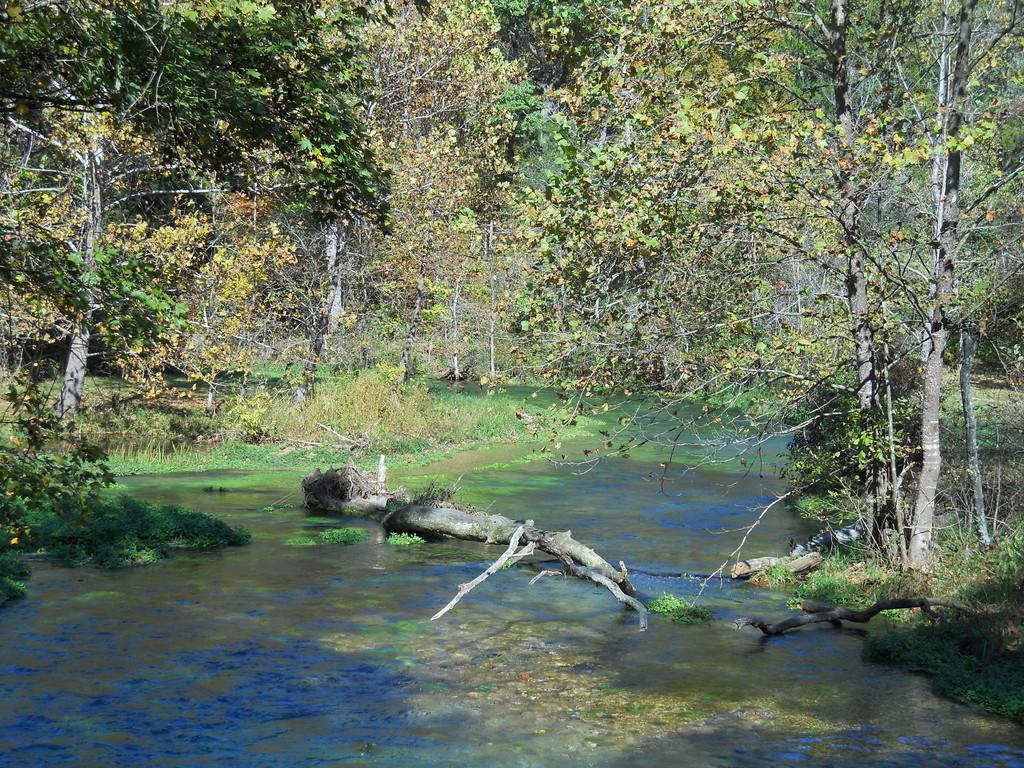In one or two sentences, can you explain what this image depicts? In this image, in the middle there are trees, plants, grass. At the bottom there are branches, water, grass. 